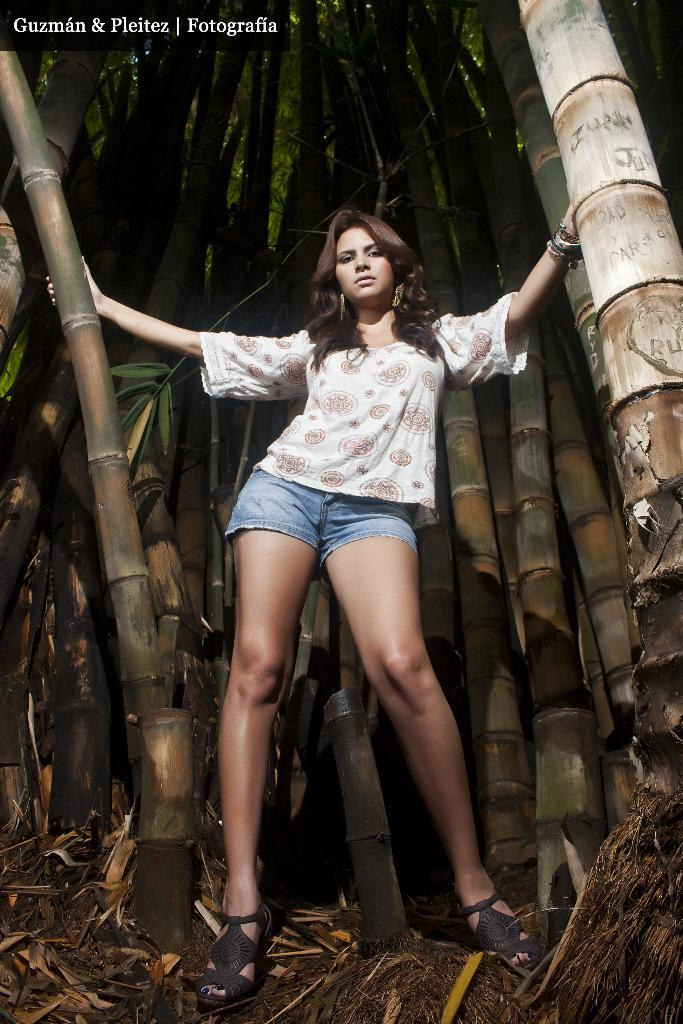What is the main subject of the image? There is a lady person in the image. What is the lady person wearing? The lady person is wearing a white color T-shirt and a blue color top. Where is the lady person standing in the image? The lady person is standing near bamboo trees. What can be seen in the background of the image? There are bamboo trees in the background of the image. What type of smell can be detected from the lady person in the image? There is no information about any smell in the image, so it cannot be determined. 